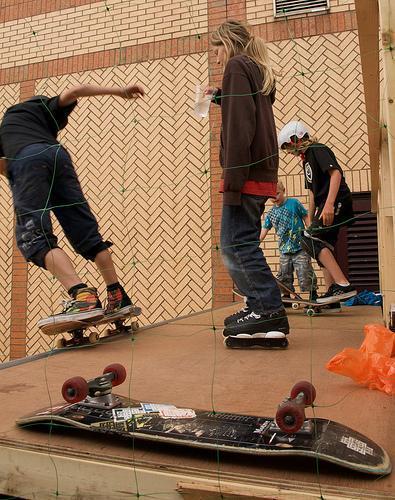How many boys are shown?
Give a very brief answer. 4. How many rollerbladers are present?
Give a very brief answer. 1. 